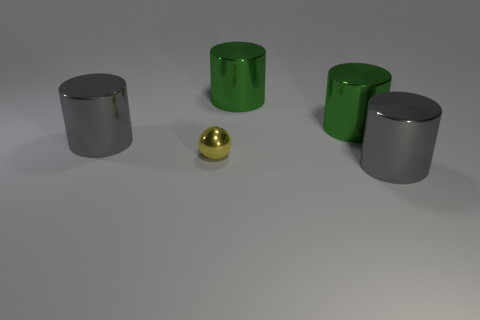What are the colors of the cylinders, and do they appear to be made of the same material? The cylinders in the image are silver and green. Each pair of cylinders seems to share the same color and reflective qualities, suggesting they are made from similar materials, likely a type of metal with a gloss finish. 